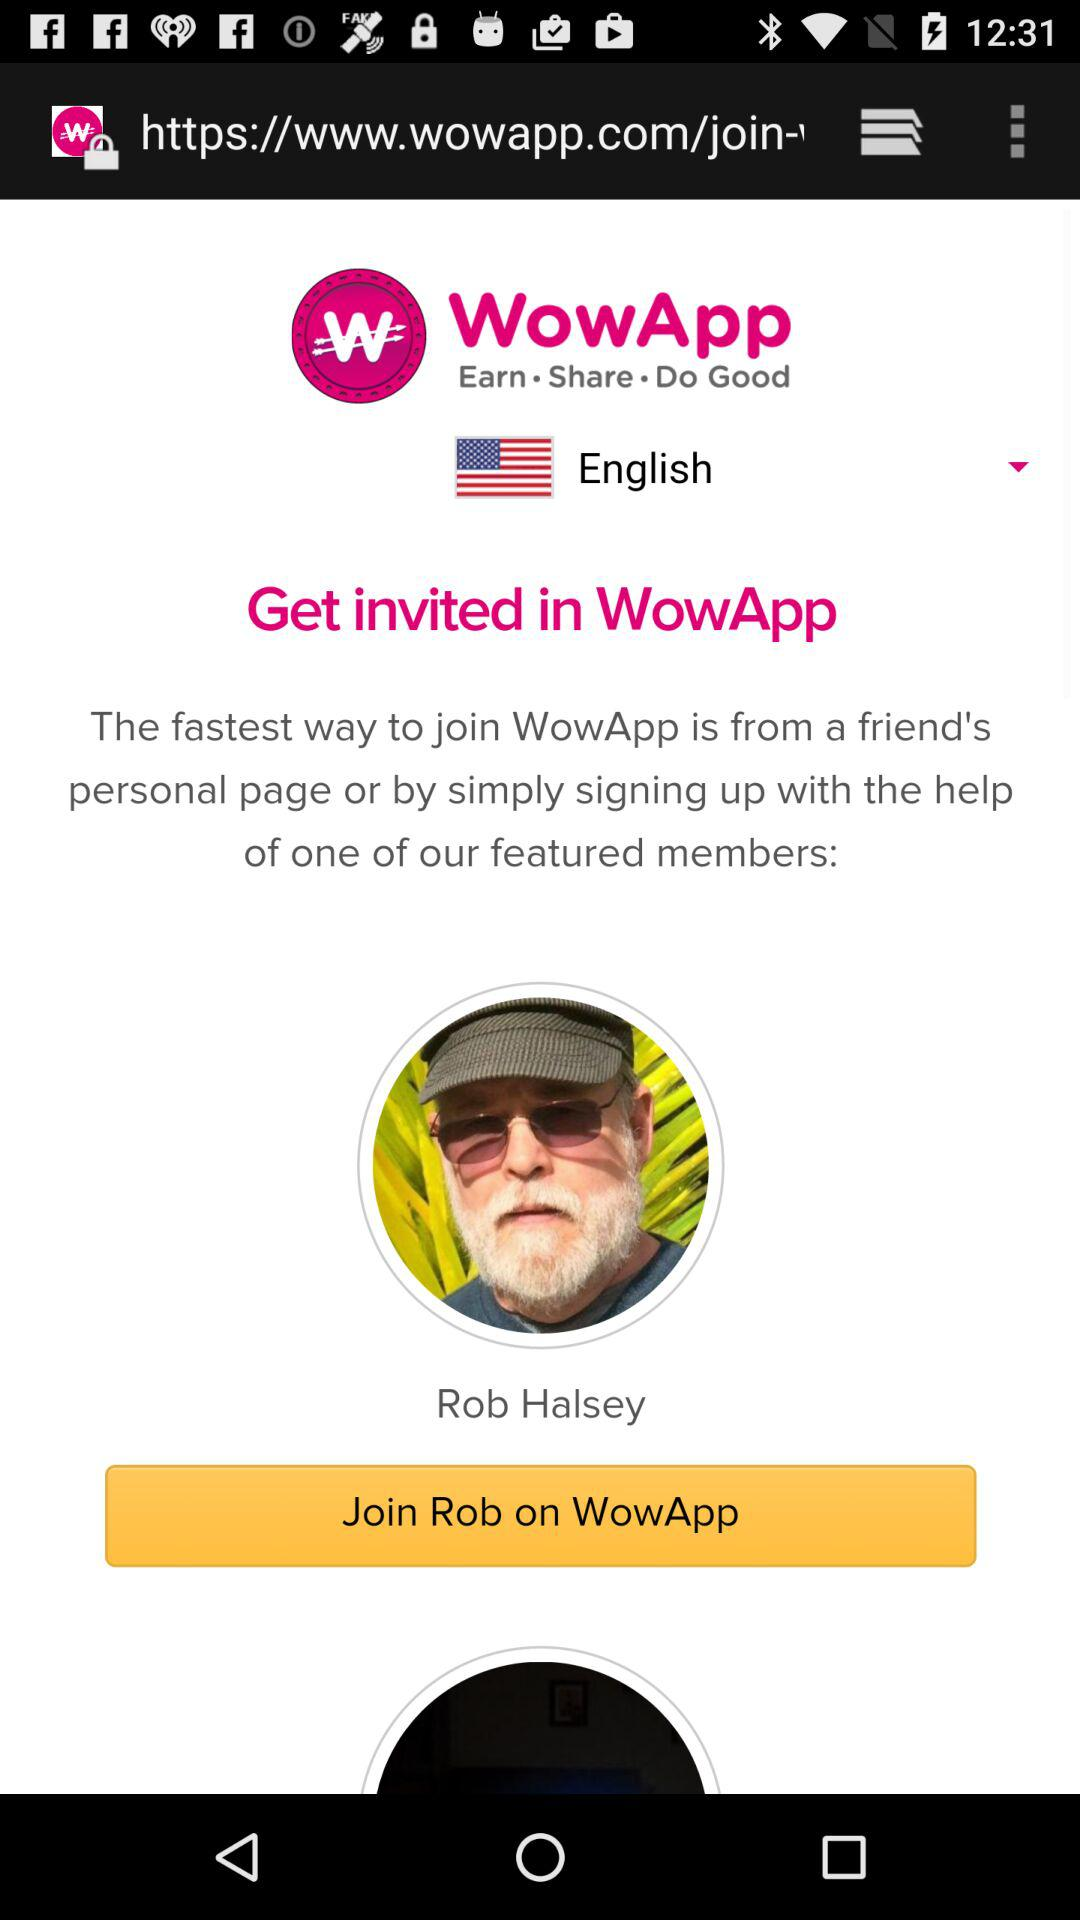What is the name of the application? The name of the application is "WowApp". 